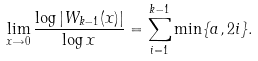Convert formula to latex. <formula><loc_0><loc_0><loc_500><loc_500>\lim _ { x \rightarrow 0 } \frac { \log | W _ { k - 1 } ( x ) | } { \log x } = \sum _ { i = 1 } ^ { k - 1 } \min \{ a , 2 i \} .</formula> 